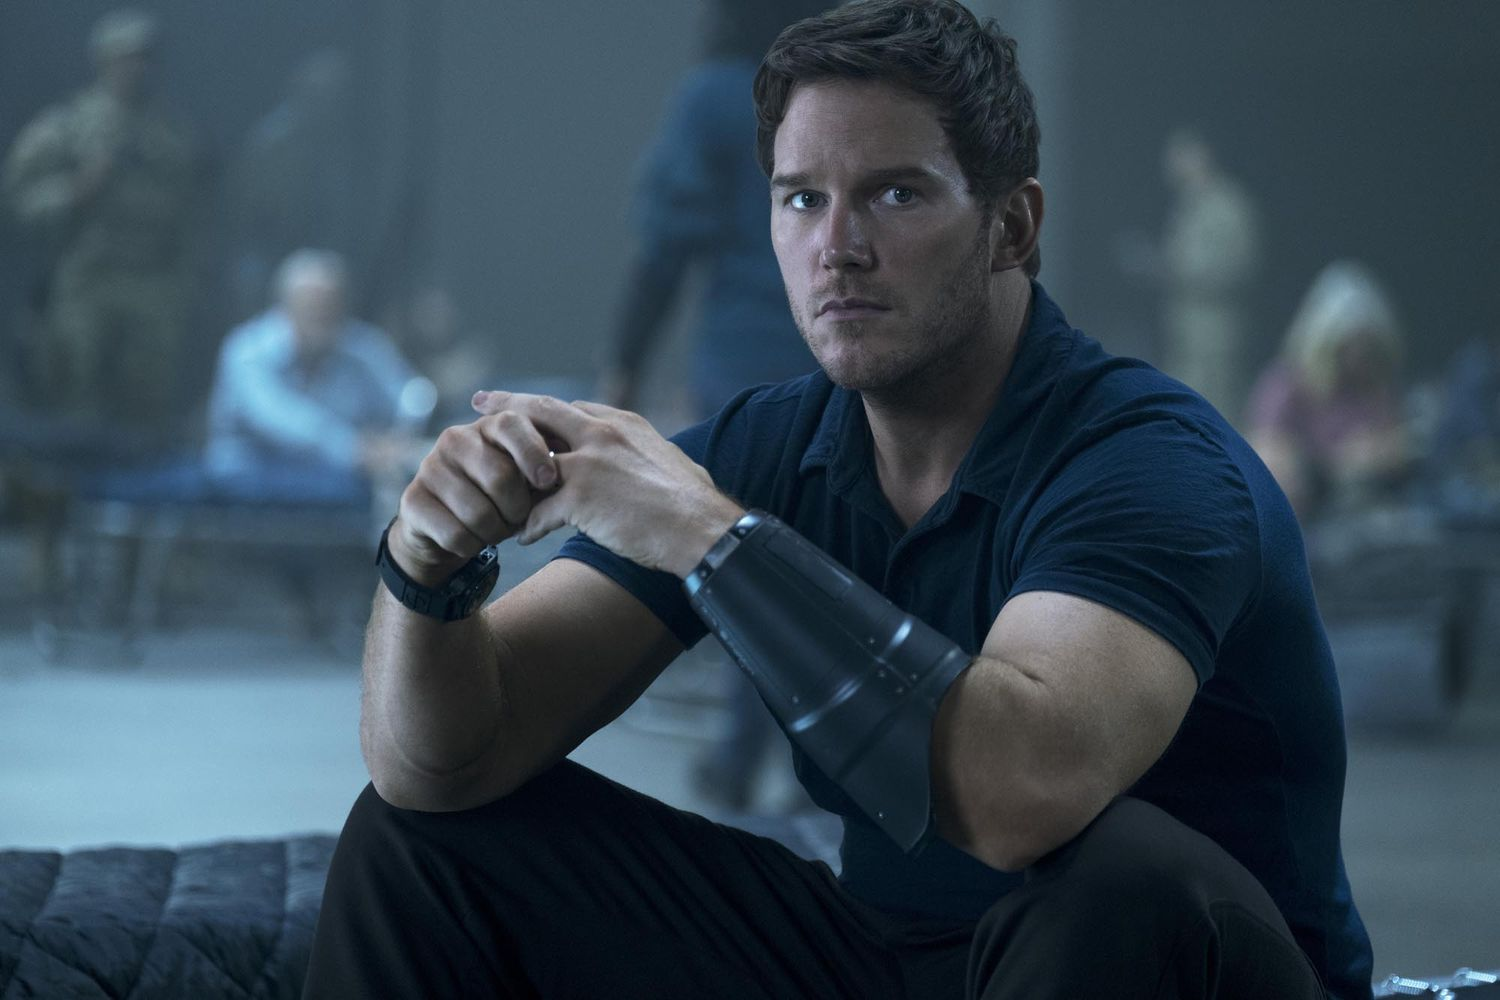What are the key elements in this picture? The image features an individual with a focused expression, wearing a dark blue shirt and a prosthetic device on their left arm. They are seated on a bench, and the blurred background shows other people, possibly in a cafeteria or a public space, conveying a busy atmosphere. The setting and the intensity of the individual suggest a scene from a narrative or dramatic context. 